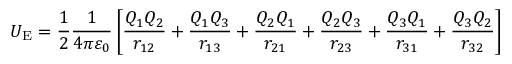Convert formula to latex. <formula><loc_0><loc_0><loc_500><loc_500>U _ { E } = { \frac { 1 } { 2 } } { \frac { 1 } { 4 \pi \varepsilon _ { 0 } } } \left [ { \frac { Q _ { 1 } Q _ { 2 } } { r _ { 1 2 } } } + { \frac { Q _ { 1 } Q _ { 3 } } { r _ { 1 3 } } } + { \frac { Q _ { 2 } Q _ { 1 } } { r _ { 2 1 } } } + { \frac { Q _ { 2 } Q _ { 3 } } { r _ { 2 3 } } } + { \frac { Q _ { 3 } Q _ { 1 } } { r _ { 3 1 } } } + { \frac { Q _ { 3 } Q _ { 2 } } { r _ { 3 2 } } } \right ]</formula> 